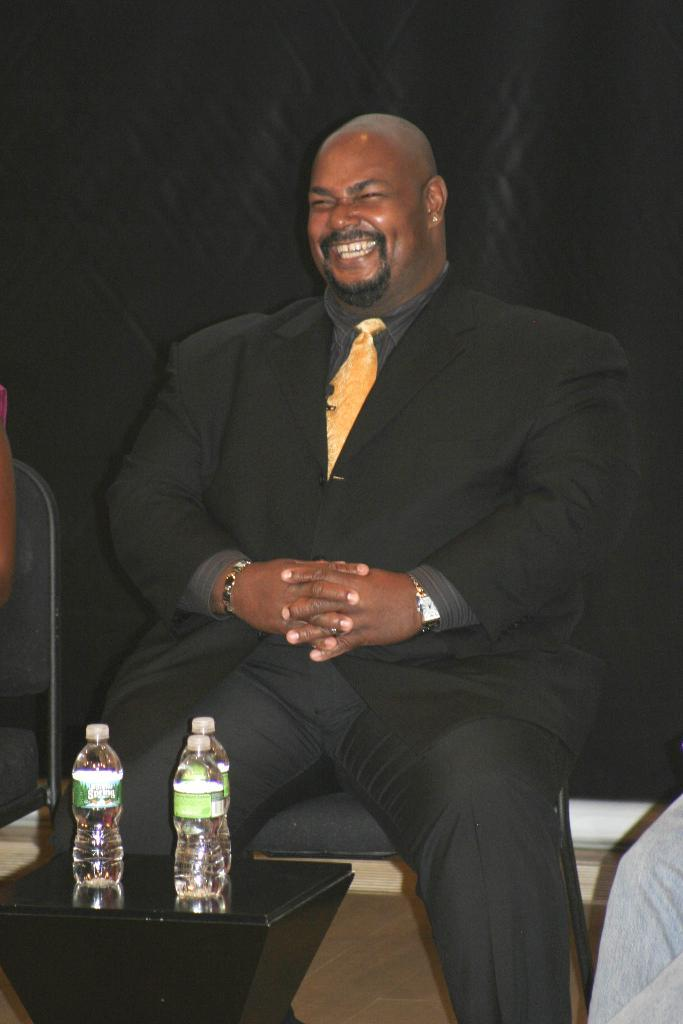Who is present in the image? There is a man in the image. What is the man doing in the image? The man is seated on a chair and smiling. What is located near the man in the image? There is a table in the image. What items can be seen on the table? There are three water bottles on the table. What type of spy equipment can be seen on the table in the image? There is no spy equipment present in the image; it features a man seated on a chair, smiling, with a table and three water bottles. What type of card game is being played in the image? There is no card game or cards present in the image. 